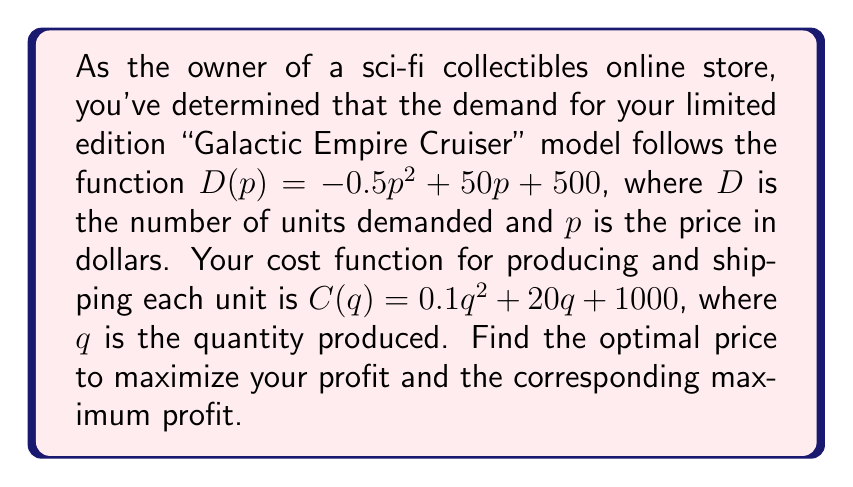Solve this math problem. 1) First, we need to express the revenue function in terms of $p$:
   $R(p) = p \cdot D(p) = p(-0.5p^2 + 50p + 500) = -0.5p^3 + 50p^2 + 500p$

2) To find the cost function in terms of $p$, we substitute $D(p)$ for $q$:
   $C(p) = 0.1(-0.5p^2 + 50p + 500)^2 + 20(-0.5p^2 + 50p + 500) + 1000$
   $= 0.025p^4 - 5p^3 + 375p^2 - 10p^2 + 1000p + 25000 + 10000 - 1000p + 1000$
   $= 0.025p^4 - 5p^3 + 365p^2 + 36000$

3) The profit function is revenue minus cost:
   $P(p) = R(p) - C(p)$
   $= (-0.5p^3 + 50p^2 + 500p) - (0.025p^4 - 5p^3 + 365p^2 + 36000)$
   $= -0.025p^4 + 4.5p^3 - 315p^2 + 500p - 36000$

4) To find the maximum profit, we differentiate $P(p)$ and set it to zero:
   $P'(p) = -0.1p^3 + 13.5p^2 - 630p + 500 = 0$

5) This cubic equation is difficult to solve analytically. Using a numerical method (e.g., Newton-Raphson) or graphing calculator, we find that the solution is approximately $p \approx 51.67$.

6) To confirm this is a maximum, we can check that $P''(p) < 0$ at this point:
   $P''(p) = -0.3p^2 + 27p - 630$
   $P''(51.67) \approx -630.5 < 0$, confirming it's a maximum.

7) The maximum profit is found by plugging $p = 51.67$ into $P(p)$:
   $P(51.67) \approx 27,121.33$
Answer: Optimal price: $51.67; Maximum profit: $27,121.33 